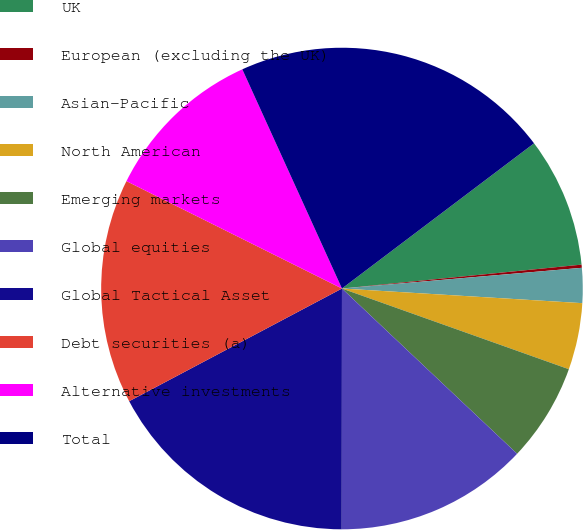Convert chart to OTSL. <chart><loc_0><loc_0><loc_500><loc_500><pie_chart><fcel>UK<fcel>European (excluding the UK)<fcel>Asian-Pacific<fcel>North American<fcel>Emerging markets<fcel>Global equities<fcel>Global Tactical Asset<fcel>Debt securities (a)<fcel>Alternative investments<fcel>Total<nl><fcel>8.72%<fcel>0.21%<fcel>2.34%<fcel>4.47%<fcel>6.6%<fcel>12.98%<fcel>17.23%<fcel>15.11%<fcel>10.85%<fcel>21.49%<nl></chart> 